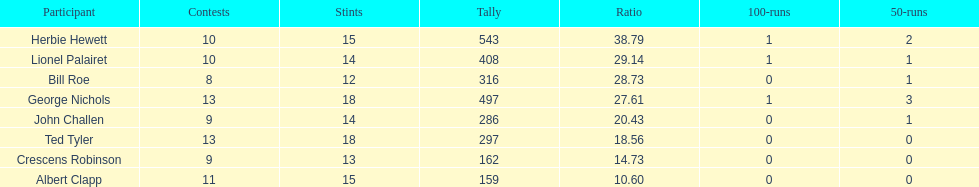How many innings did bill and ted have in total? 30. 